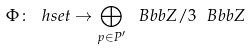Convert formula to latex. <formula><loc_0><loc_0><loc_500><loc_500>\Phi \colon \ h s e t \to \bigoplus _ { p \in P ^ { \prime } } \ B b b Z / 3 \ B b b Z</formula> 